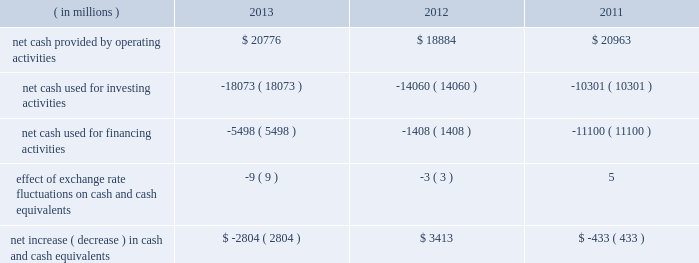In summary , our cash flows for each period were as follows: .
Operating activities cash provided by operating activities is net income adjusted for certain non-cash items and changes in certain assets and liabilities .
For 2013 compared to 2012 , the $ 1.9 billion increase in cash provided by operating activities was due to changes in working capital , partially offset by lower net income in 2013 .
Income taxes paid , net of refunds , in 2013 compared to 2012 were $ 1.1 billion lower due to lower income before taxes in 2013 and 2012 income tax overpayments .
Changes in assets and liabilities as of december 28 , 2013 , compared to december 29 , 2012 , included lower income taxes payable and receivable resulting from a reduction in taxes due in 2013 , and lower inventories due to the sell-through of older-generation products , partially offset by the ramp of 4th generation intel core processor family products .
For 2013 , our three largest customers accounted for 44% ( 44 % ) of our net revenue ( 43% ( 43 % ) in 2012 and 2011 ) , with hewlett- packard company accounting for 17% ( 17 % ) of our net revenue ( 18% ( 18 % ) in 2012 and 19% ( 19 % ) in 2011 ) , dell accounting for 15% ( 15 % ) of our net revenue ( 14% ( 14 % ) in 2012 and 15% ( 15 % ) in 2011 ) , and lenovo accounting for 12% ( 12 % ) of our net revenue ( 11% ( 11 % ) in 2012 and 9% ( 9 % ) in 2011 ) .
These three customers accounted for 34% ( 34 % ) of our accounts receivable as of december 28 , 2013 ( 33% ( 33 % ) as of december 29 , 2012 ) .
For 2012 compared to 2011 , the $ 2.1 billion decrease in cash provided by operating activities was due to lower net income and changes in our working capital , partially offset by adjustments for non-cash items .
The adjustments for noncash items were higher due primarily to higher depreciation in 2012 compared to 2011 , partially offset by increases in non-acquisition-related deferred tax liabilities as of december 31 , 2011 .
Investing activities investing cash flows consist primarily of capital expenditures ; investment purchases , sales , maturities , and disposals ; as well as cash used for acquisitions .
The increase in cash used for investing activities in 2013 compared to 2012 was primarily due to an increase in purchases of available-for-sale investments and a decrease in maturities and sales of trading assets , partially offset by an increase in maturities and sales of available-for-sale investments and a decrease in purchases of licensed technology and patents .
Our capital expenditures were $ 10.7 billion in 2013 ( $ 11.0 billion in 2012 and $ 10.8 billion in 2011 ) .
Cash used for investing activities increased in 2012 compared to 2011 primarily due to net purchases of available- for-sale investments and trading assets in 2012 , as compared to net maturities and sales of available-for-sale investments and trading assets in 2011 , partially offset by a decrease in cash paid for acquisitions .
Net purchases of available-for-sale investments in 2012 included our purchase of $ 3.2 billion of equity securities in asml in q3 2012 .
Financing activities financing cash flows consist primarily of repurchases of common stock , payment of dividends to stockholders , issuance and repayment of long-term debt , and proceeds from the sale of shares through employee equity incentive plans .
Table of contents management 2019s discussion and analysis of financial condition and results of operations ( continued ) .
In 2013 what was the approximate percentage increase in net cash provided by operating activities? 
Rationale: in 2013 net cash provided by operating activities increased by approximate 10%
Computations: (19 / 18884)
Answer: 0.00101. In summary , our cash flows for each period were as follows: .
Operating activities cash provided by operating activities is net income adjusted for certain non-cash items and changes in certain assets and liabilities .
For 2013 compared to 2012 , the $ 1.9 billion increase in cash provided by operating activities was due to changes in working capital , partially offset by lower net income in 2013 .
Income taxes paid , net of refunds , in 2013 compared to 2012 were $ 1.1 billion lower due to lower income before taxes in 2013 and 2012 income tax overpayments .
Changes in assets and liabilities as of december 28 , 2013 , compared to december 29 , 2012 , included lower income taxes payable and receivable resulting from a reduction in taxes due in 2013 , and lower inventories due to the sell-through of older-generation products , partially offset by the ramp of 4th generation intel core processor family products .
For 2013 , our three largest customers accounted for 44% ( 44 % ) of our net revenue ( 43% ( 43 % ) in 2012 and 2011 ) , with hewlett- packard company accounting for 17% ( 17 % ) of our net revenue ( 18% ( 18 % ) in 2012 and 19% ( 19 % ) in 2011 ) , dell accounting for 15% ( 15 % ) of our net revenue ( 14% ( 14 % ) in 2012 and 15% ( 15 % ) in 2011 ) , and lenovo accounting for 12% ( 12 % ) of our net revenue ( 11% ( 11 % ) in 2012 and 9% ( 9 % ) in 2011 ) .
These three customers accounted for 34% ( 34 % ) of our accounts receivable as of december 28 , 2013 ( 33% ( 33 % ) as of december 29 , 2012 ) .
For 2012 compared to 2011 , the $ 2.1 billion decrease in cash provided by operating activities was due to lower net income and changes in our working capital , partially offset by adjustments for non-cash items .
The adjustments for noncash items were higher due primarily to higher depreciation in 2012 compared to 2011 , partially offset by increases in non-acquisition-related deferred tax liabilities as of december 31 , 2011 .
Investing activities investing cash flows consist primarily of capital expenditures ; investment purchases , sales , maturities , and disposals ; as well as cash used for acquisitions .
The increase in cash used for investing activities in 2013 compared to 2012 was primarily due to an increase in purchases of available-for-sale investments and a decrease in maturities and sales of trading assets , partially offset by an increase in maturities and sales of available-for-sale investments and a decrease in purchases of licensed technology and patents .
Our capital expenditures were $ 10.7 billion in 2013 ( $ 11.0 billion in 2012 and $ 10.8 billion in 2011 ) .
Cash used for investing activities increased in 2012 compared to 2011 primarily due to net purchases of available- for-sale investments and trading assets in 2012 , as compared to net maturities and sales of available-for-sale investments and trading assets in 2011 , partially offset by a decrease in cash paid for acquisitions .
Net purchases of available-for-sale investments in 2012 included our purchase of $ 3.2 billion of equity securities in asml in q3 2012 .
Financing activities financing cash flows consist primarily of repurchases of common stock , payment of dividends to stockholders , issuance and repayment of long-term debt , and proceeds from the sale of shares through employee equity incentive plans .
Table of contents management 2019s discussion and analysis of financial condition and results of operations ( continued ) .
In 2013 what was the percent of the net cash used for investing activities to the net cash provided by operating activities? 
Rationale: in 2013 86.9% of the net cash provided by operating activities was used for investing activities
Computations: (18073 / 20776)
Answer: 0.8699. 